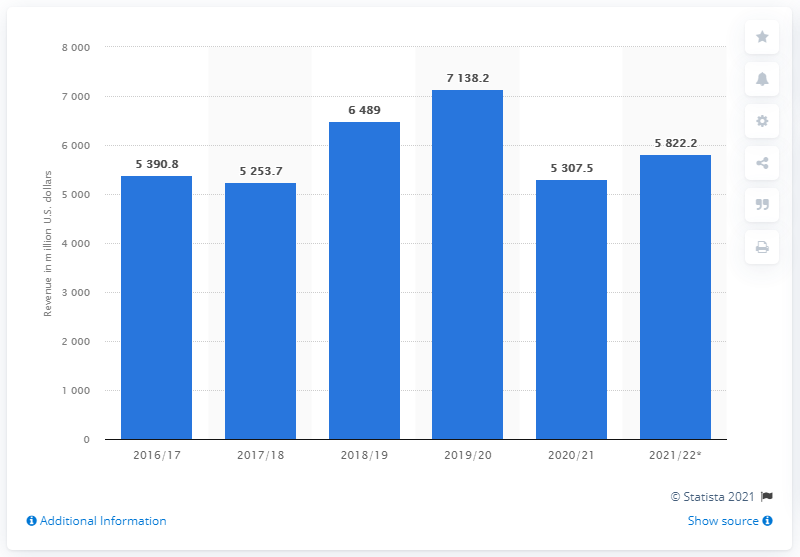Specify some key components in this picture. In the fiscal year of 2020/21, PetSmart's revenue was approximately $5307.5 million. 